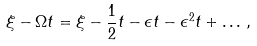Convert formula to latex. <formula><loc_0><loc_0><loc_500><loc_500>\xi - \Omega t = \xi - \frac { 1 } { 2 } t - \epsilon t - \epsilon ^ { 2 } t + \dots \, ,</formula> 